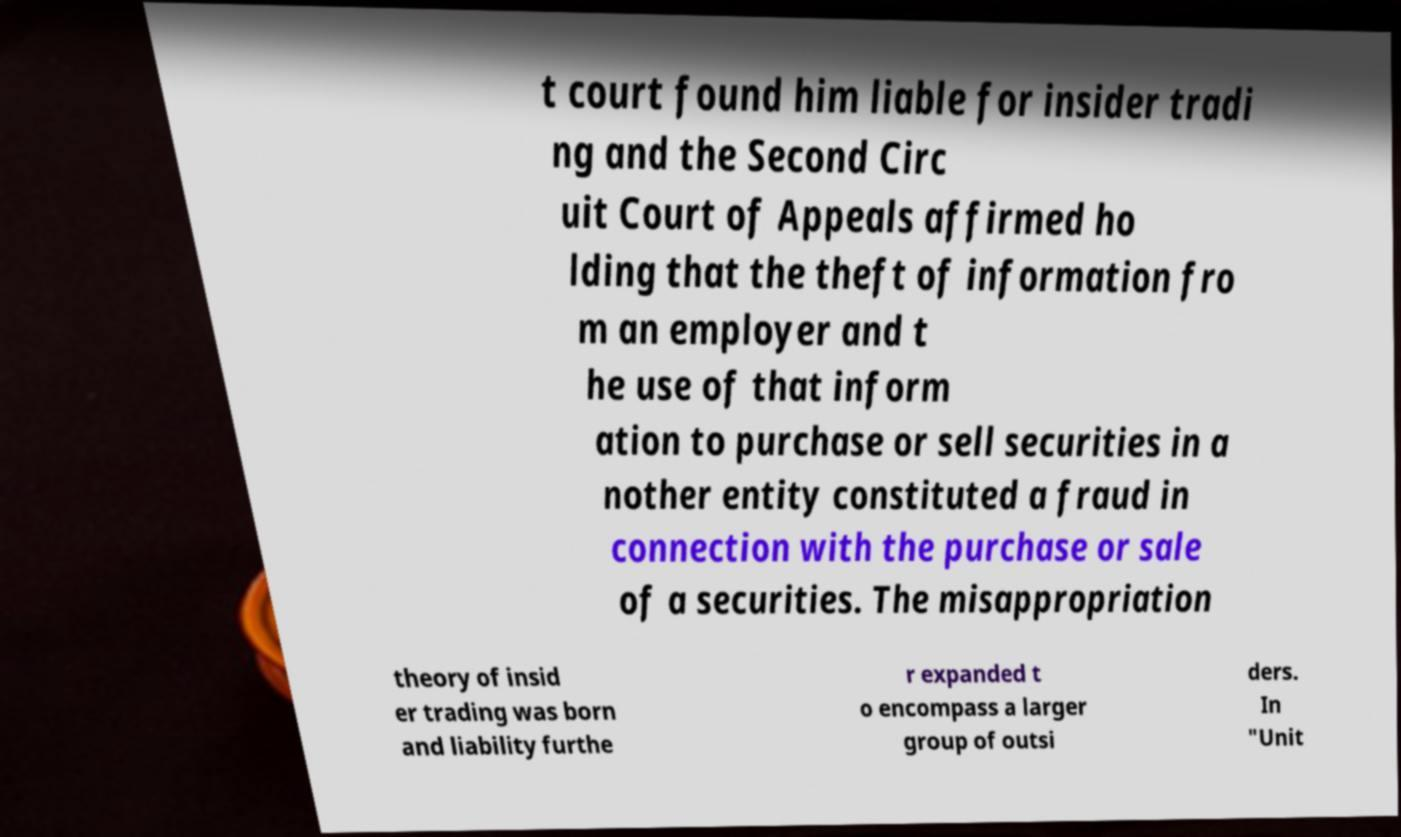I need the written content from this picture converted into text. Can you do that? t court found him liable for insider tradi ng and the Second Circ uit Court of Appeals affirmed ho lding that the theft of information fro m an employer and t he use of that inform ation to purchase or sell securities in a nother entity constituted a fraud in connection with the purchase or sale of a securities. The misappropriation theory of insid er trading was born and liability furthe r expanded t o encompass a larger group of outsi ders. In "Unit 